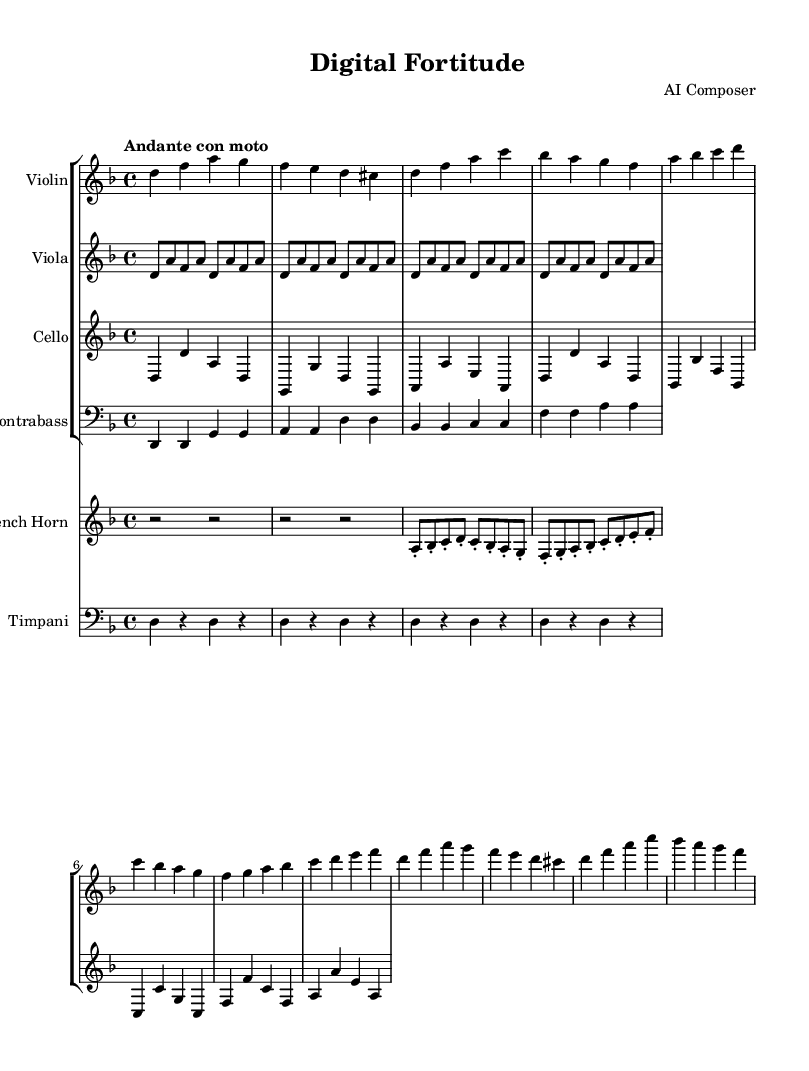What is the key signature of this music? The key signature is two flats, indicating it is composed in D minor. The key signature can be identified at the beginning of the staff where D minor appears.
Answer: D minor What is the time signature of the piece? The time signature is 4/4, which can be found at the beginning of the score, showing that there are four beats in each measure.
Answer: 4/4 What is the tempo marking of the piece? The tempo marking is "Andante con moto," which implies a moderate tempo that conveys a sense of motion. This is stated at the beginning of the music notation.
Answer: Andante con moto What instruments are included in the orchestration? The orchestration includes violin, viola, cello, contrabass, french horn, and timpani, as indicated by the labeled staves in the score.
Answer: Violin, Viola, Cello, Contrabass, French Horn, Timpani What thematic element does the ostinato in the viola represent? The ostinato in the viola represents a repetitive and suspenseful background element that supports the main theme, contributing to the feelings of tension and anticipation typical in suspenseful orchestral music. This can be concluded by analyzing the repetitive pattern in the vocal line against the main themes.
Answer: Suspenseful background How does the climax of the piece compare to the main theme? The climax introduces heightened tension, using the same notes as the main theme but played with greater intensity and dynamics. By cross-referencing the climax section notes with the main theme, one can observe the same melodic structure is utilized but is developed further to enhance emotional impact.
Answer: Heightened tension 